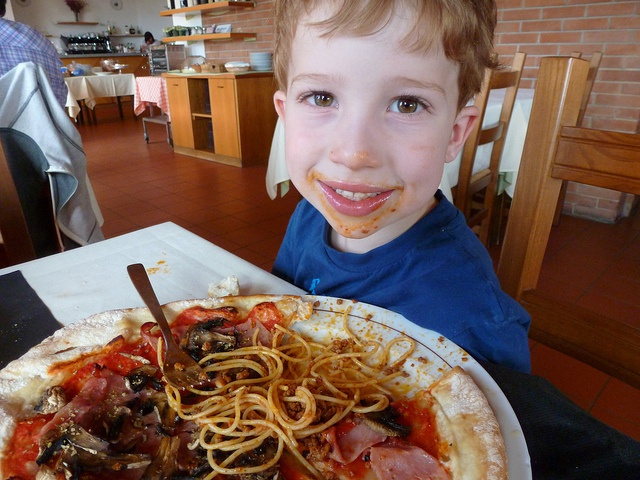Describe the objects in this image and their specific colors. I can see dining table in black, maroon, lightgray, and brown tones, people in black, navy, darkgray, lightgray, and gray tones, chair in black, maroon, brown, and gray tones, chair in black, maroon, and darkgray tones, and chair in black, maroon, and blue tones in this image. 